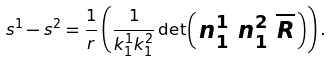Convert formula to latex. <formula><loc_0><loc_0><loc_500><loc_500>s ^ { 1 } - s ^ { 2 } = \frac { 1 } { r } \left ( \frac { 1 } { k ^ { 1 } _ { 1 } k ^ { 2 } _ { 1 } } \det \begin{psmallmatrix} n ^ { 1 } _ { 1 } & n ^ { 2 } _ { 1 } & \overline { R } \end{psmallmatrix} \right ) .</formula> 